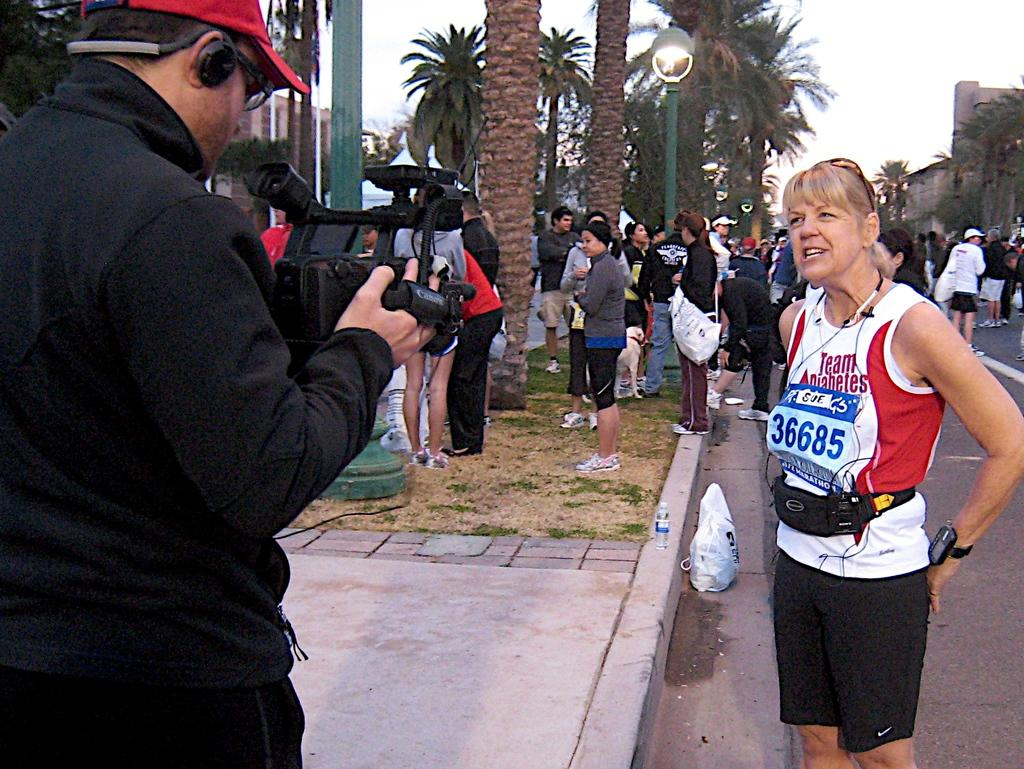<image>
Provide a brief description of the given image. Racer 36685 stands in the street having her picture taken. 